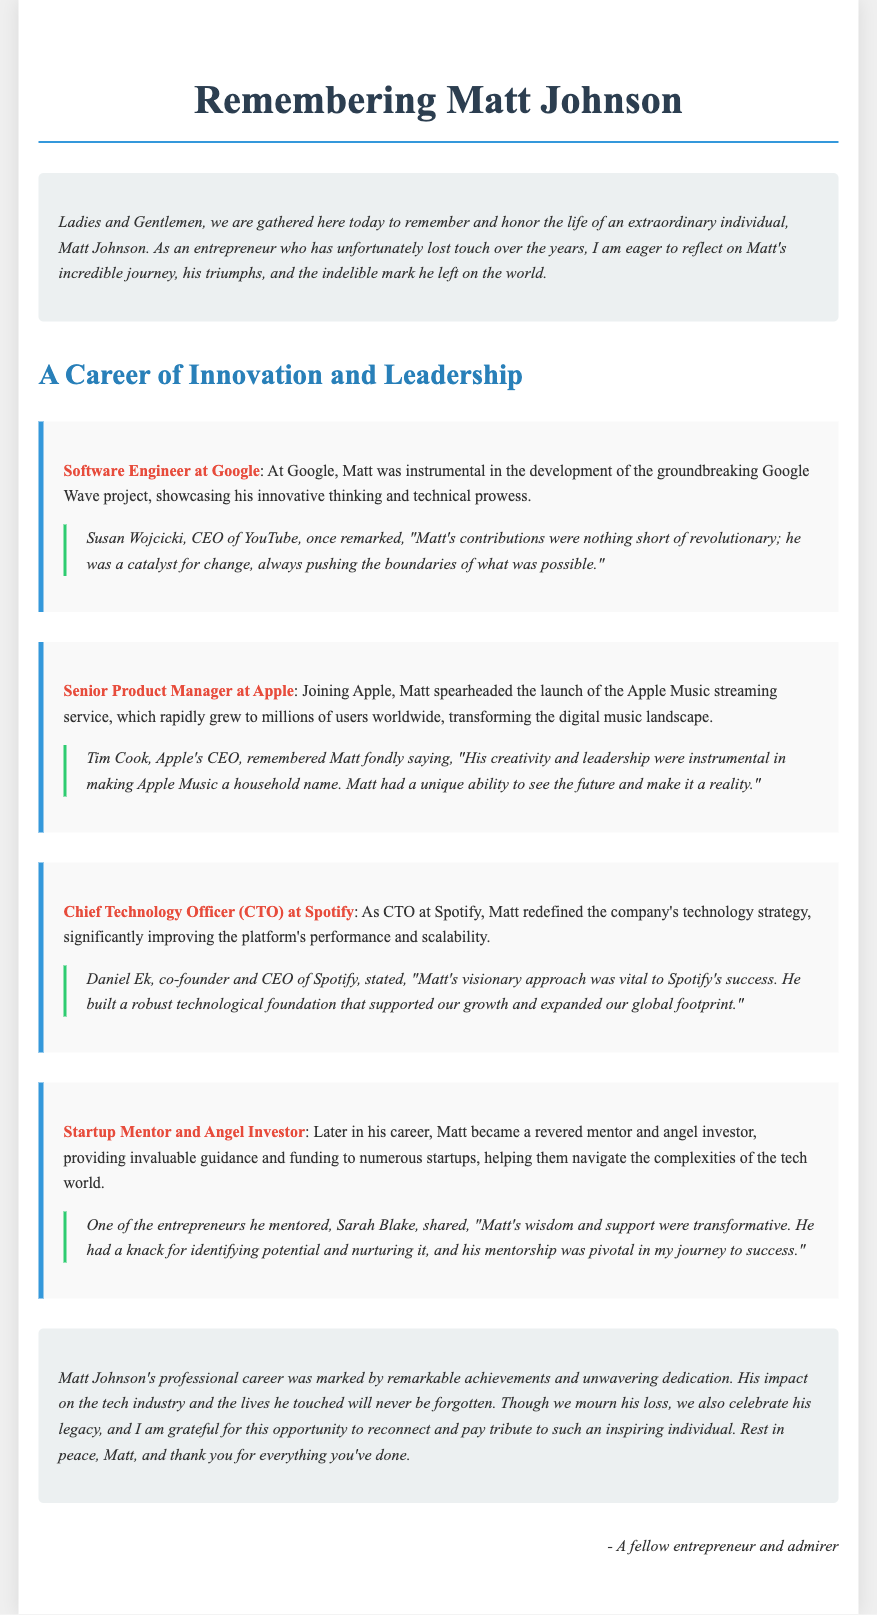What role did Matt have at Google? Matt was a Software Engineer at Google, where he worked on the Google Wave project.
Answer: Software Engineer What was Matt's significant contribution at Apple? At Apple, Matt spearheaded the launch of Apple Music, transforming the digital music landscape.
Answer: Apple Music Who is quoted in the document mentioning Matt's contributions at Google? Susan Wojcicki, CEO of YouTube, remarked about Matt's revolutionary contributions.
Answer: Susan Wojcicki What position did Matt hold at Spotify? Matt was the Chief Technology Officer (CTO) at Spotify.
Answer: Chief Technology Officer Which startup did Matt mentor that is mentioned in the document? The entrepreneur Sarah Blake is mentioned as someone Matt mentored.
Answer: Sarah Blake What did Tim Cook say about Matt's ability? Tim Cook noted Matt had a unique ability to see the future and make it a reality.
Answer: See the future How did Matt impact startups later in his career? Matt became a revered mentor and angel investor, providing guidance and funding.
Answer: Mentor and angel investor What were Matt's accomplishments primarily categorized under in the document? Matt's professional career achievements were categorized under Innovation and Leadership.
Answer: Innovation and Leadership What is one word to describe Matt's professional legacy? The document refers to Matt's legacy as inspiring.
Answer: Inspiring 